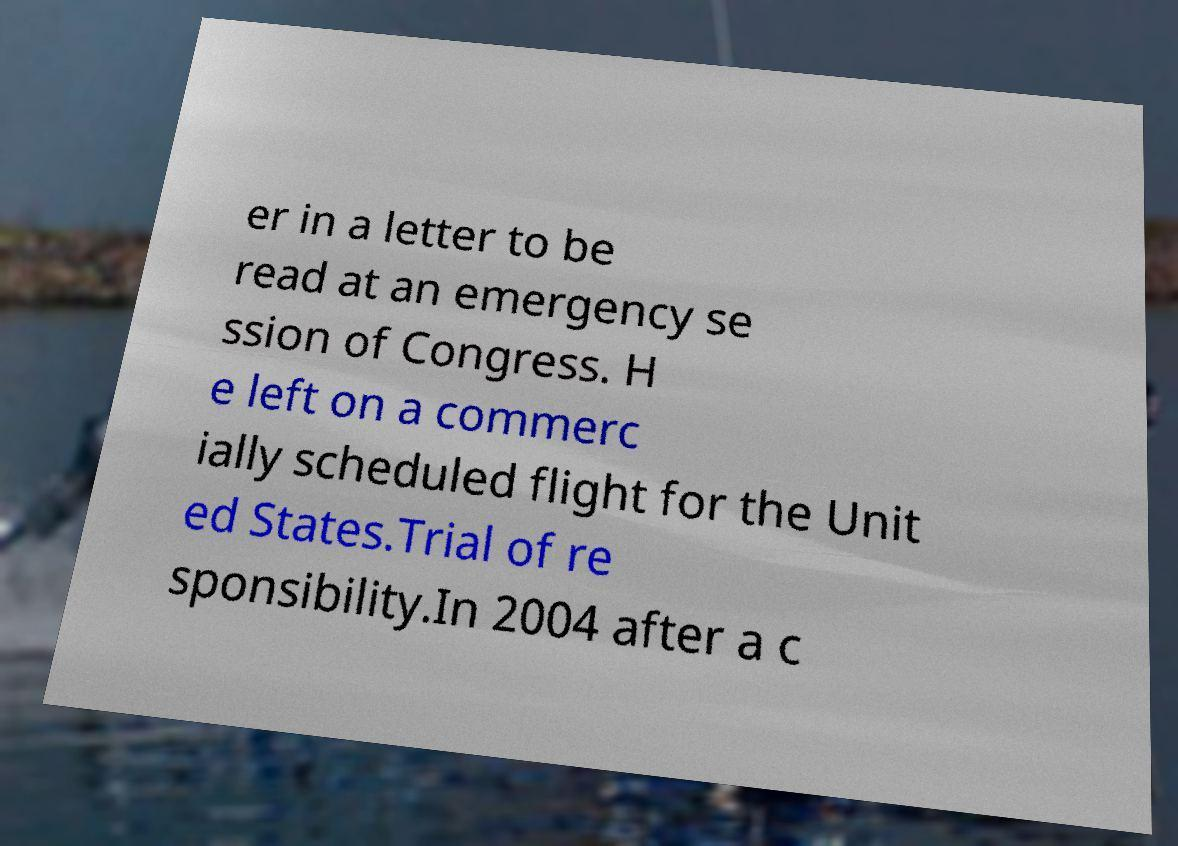I need the written content from this picture converted into text. Can you do that? er in a letter to be read at an emergency se ssion of Congress. H e left on a commerc ially scheduled flight for the Unit ed States.Trial of re sponsibility.In 2004 after a c 